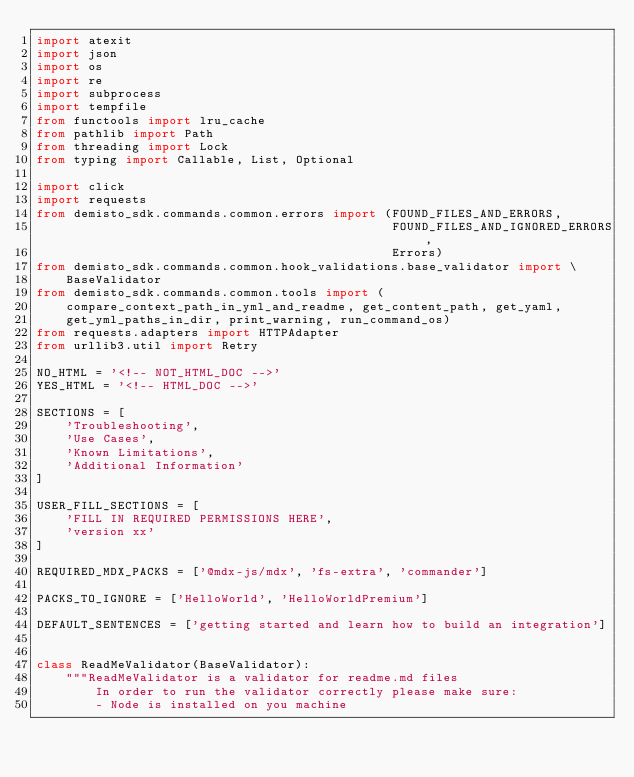Convert code to text. <code><loc_0><loc_0><loc_500><loc_500><_Python_>import atexit
import json
import os
import re
import subprocess
import tempfile
from functools import lru_cache
from pathlib import Path
from threading import Lock
from typing import Callable, List, Optional

import click
import requests
from demisto_sdk.commands.common.errors import (FOUND_FILES_AND_ERRORS,
                                                FOUND_FILES_AND_IGNORED_ERRORS,
                                                Errors)
from demisto_sdk.commands.common.hook_validations.base_validator import \
    BaseValidator
from demisto_sdk.commands.common.tools import (
    compare_context_path_in_yml_and_readme, get_content_path, get_yaml,
    get_yml_paths_in_dir, print_warning, run_command_os)
from requests.adapters import HTTPAdapter
from urllib3.util import Retry

NO_HTML = '<!-- NOT_HTML_DOC -->'
YES_HTML = '<!-- HTML_DOC -->'

SECTIONS = [
    'Troubleshooting',
    'Use Cases',
    'Known Limitations',
    'Additional Information'
]

USER_FILL_SECTIONS = [
    'FILL IN REQUIRED PERMISSIONS HERE',
    'version xx'
]

REQUIRED_MDX_PACKS = ['@mdx-js/mdx', 'fs-extra', 'commander']

PACKS_TO_IGNORE = ['HelloWorld', 'HelloWorldPremium']

DEFAULT_SENTENCES = ['getting started and learn how to build an integration']


class ReadMeValidator(BaseValidator):
    """ReadMeValidator is a validator for readme.md files
        In order to run the validator correctly please make sure:
        - Node is installed on you machine</code> 